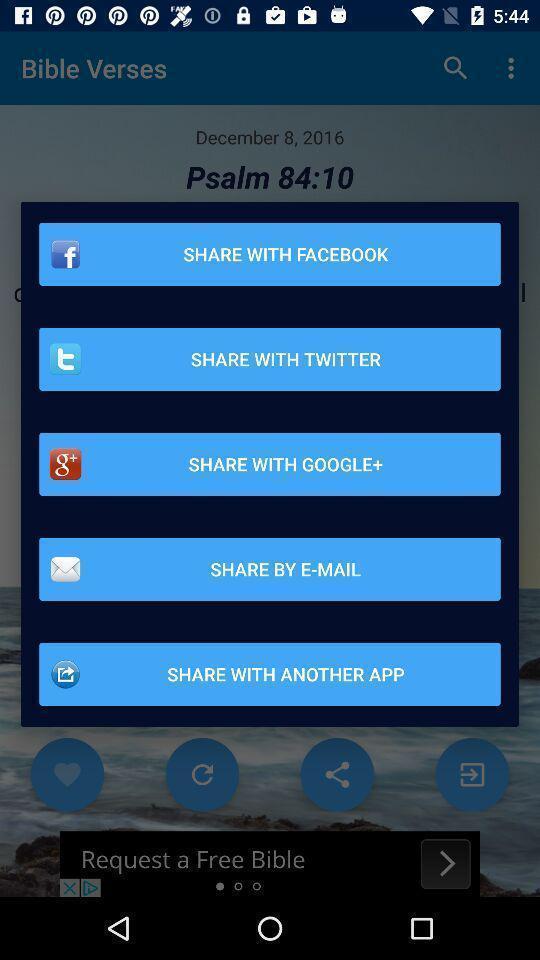Describe the content in this image. Pop-up showing multiple application to share. 